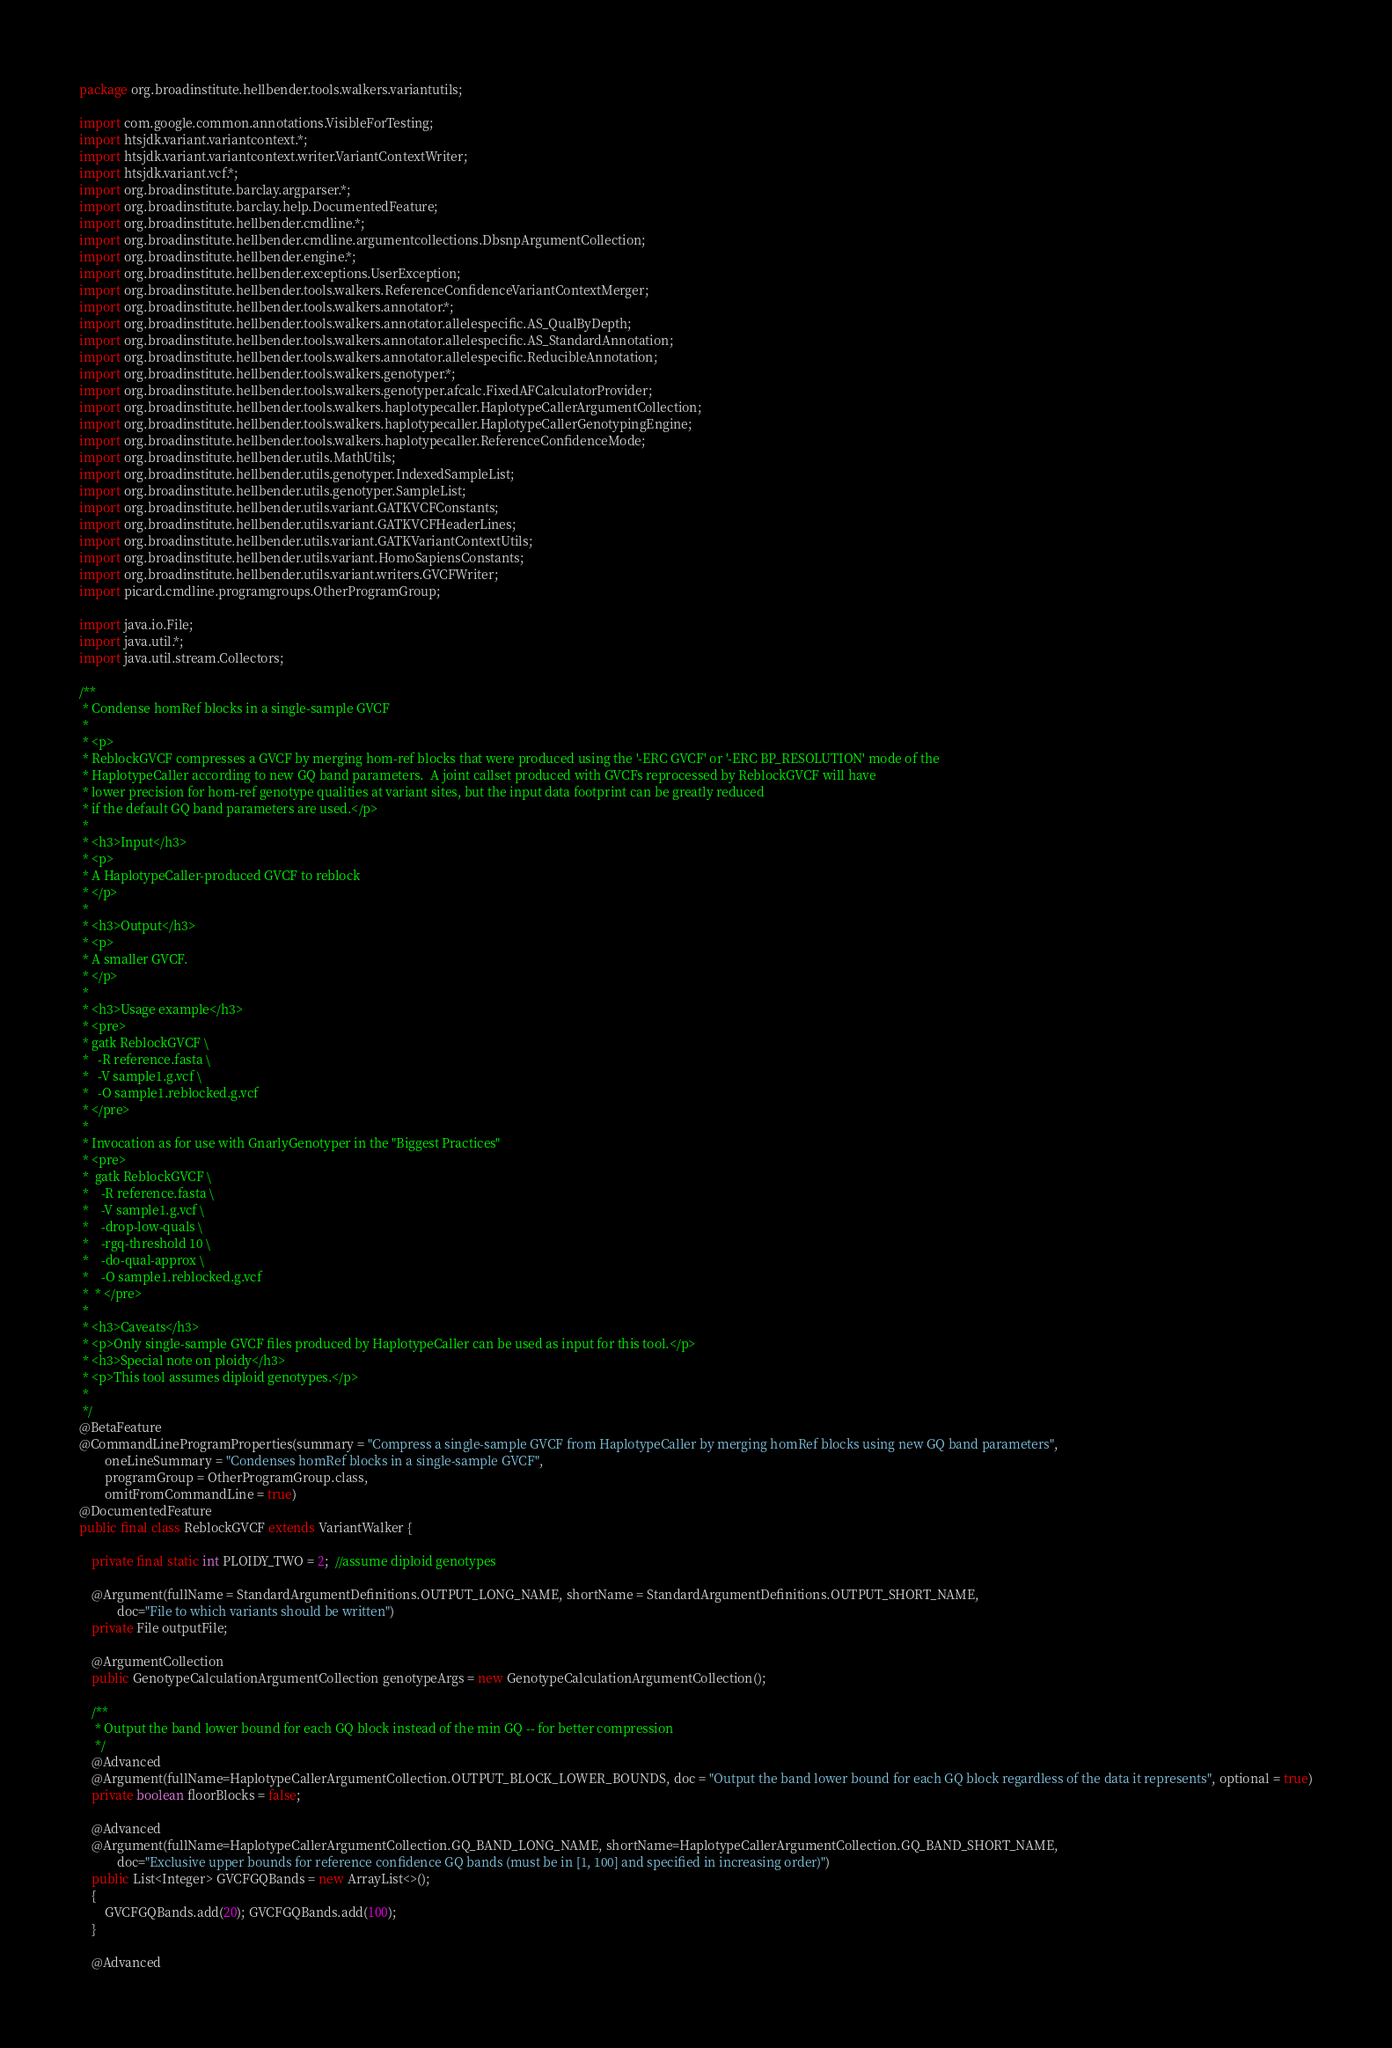<code> <loc_0><loc_0><loc_500><loc_500><_Java_>package org.broadinstitute.hellbender.tools.walkers.variantutils;

import com.google.common.annotations.VisibleForTesting;
import htsjdk.variant.variantcontext.*;
import htsjdk.variant.variantcontext.writer.VariantContextWriter;
import htsjdk.variant.vcf.*;
import org.broadinstitute.barclay.argparser.*;
import org.broadinstitute.barclay.help.DocumentedFeature;
import org.broadinstitute.hellbender.cmdline.*;
import org.broadinstitute.hellbender.cmdline.argumentcollections.DbsnpArgumentCollection;
import org.broadinstitute.hellbender.engine.*;
import org.broadinstitute.hellbender.exceptions.UserException;
import org.broadinstitute.hellbender.tools.walkers.ReferenceConfidenceVariantContextMerger;
import org.broadinstitute.hellbender.tools.walkers.annotator.*;
import org.broadinstitute.hellbender.tools.walkers.annotator.allelespecific.AS_QualByDepth;
import org.broadinstitute.hellbender.tools.walkers.annotator.allelespecific.AS_StandardAnnotation;
import org.broadinstitute.hellbender.tools.walkers.annotator.allelespecific.ReducibleAnnotation;
import org.broadinstitute.hellbender.tools.walkers.genotyper.*;
import org.broadinstitute.hellbender.tools.walkers.genotyper.afcalc.FixedAFCalculatorProvider;
import org.broadinstitute.hellbender.tools.walkers.haplotypecaller.HaplotypeCallerArgumentCollection;
import org.broadinstitute.hellbender.tools.walkers.haplotypecaller.HaplotypeCallerGenotypingEngine;
import org.broadinstitute.hellbender.tools.walkers.haplotypecaller.ReferenceConfidenceMode;
import org.broadinstitute.hellbender.utils.MathUtils;
import org.broadinstitute.hellbender.utils.genotyper.IndexedSampleList;
import org.broadinstitute.hellbender.utils.genotyper.SampleList;
import org.broadinstitute.hellbender.utils.variant.GATKVCFConstants;
import org.broadinstitute.hellbender.utils.variant.GATKVCFHeaderLines;
import org.broadinstitute.hellbender.utils.variant.GATKVariantContextUtils;
import org.broadinstitute.hellbender.utils.variant.HomoSapiensConstants;
import org.broadinstitute.hellbender.utils.variant.writers.GVCFWriter;
import picard.cmdline.programgroups.OtherProgramGroup;

import java.io.File;
import java.util.*;
import java.util.stream.Collectors;

/**
 * Condense homRef blocks in a single-sample GVCF
 *
 * <p>
 * ReblockGVCF compresses a GVCF by merging hom-ref blocks that were produced using the '-ERC GVCF' or '-ERC BP_RESOLUTION' mode of the
 * HaplotypeCaller according to new GQ band parameters.  A joint callset produced with GVCFs reprocessed by ReblockGVCF will have
 * lower precision for hom-ref genotype qualities at variant sites, but the input data footprint can be greatly reduced
 * if the default GQ band parameters are used.</p>
 *
 * <h3>Input</h3>
 * <p>
 * A HaplotypeCaller-produced GVCF to reblock
 * </p>
 *
 * <h3>Output</h3>
 * <p>
 * A smaller GVCF.
 * </p>
 *
 * <h3>Usage example</h3>
 * <pre>
 * gatk ReblockGVCF \
 *   -R reference.fasta \
 *   -V sample1.g.vcf \
 *   -O sample1.reblocked.g.vcf
 * </pre>
 *
 * Invocation as for use with GnarlyGenotyper in the "Biggest Practices"
 * <pre>
 *  gatk ReblockGVCF \
 *    -R reference.fasta \
 *    -V sample1.g.vcf \
 *    -drop-low-quals \
 *    -rgq-threshold 10 \
 *    -do-qual-approx \
 *    -O sample1.reblocked.g.vcf
 *  * </pre>
 *
 * <h3>Caveats</h3>
 * <p>Only single-sample GVCF files produced by HaplotypeCaller can be used as input for this tool.</p>
 * <h3>Special note on ploidy</h3>
 * <p>This tool assumes diploid genotypes.</p>
 *
 */
@BetaFeature
@CommandLineProgramProperties(summary = "Compress a single-sample GVCF from HaplotypeCaller by merging homRef blocks using new GQ band parameters",
        oneLineSummary = "Condenses homRef blocks in a single-sample GVCF",
        programGroup = OtherProgramGroup.class,
        omitFromCommandLine = true)
@DocumentedFeature
public final class ReblockGVCF extends VariantWalker {

    private final static int PLOIDY_TWO = 2;  //assume diploid genotypes

    @Argument(fullName = StandardArgumentDefinitions.OUTPUT_LONG_NAME, shortName = StandardArgumentDefinitions.OUTPUT_SHORT_NAME,
            doc="File to which variants should be written")
    private File outputFile;

    @ArgumentCollection
    public GenotypeCalculationArgumentCollection genotypeArgs = new GenotypeCalculationArgumentCollection();

    /**
     * Output the band lower bound for each GQ block instead of the min GQ -- for better compression
     */
    @Advanced
    @Argument(fullName=HaplotypeCallerArgumentCollection.OUTPUT_BLOCK_LOWER_BOUNDS, doc = "Output the band lower bound for each GQ block regardless of the data it represents", optional = true)
    private boolean floorBlocks = false;

    @Advanced
    @Argument(fullName=HaplotypeCallerArgumentCollection.GQ_BAND_LONG_NAME, shortName=HaplotypeCallerArgumentCollection.GQ_BAND_SHORT_NAME,
            doc="Exclusive upper bounds for reference confidence GQ bands (must be in [1, 100] and specified in increasing order)")
    public List<Integer> GVCFGQBands = new ArrayList<>();
    {
        GVCFGQBands.add(20); GVCFGQBands.add(100);
    }

    @Advanced</code> 